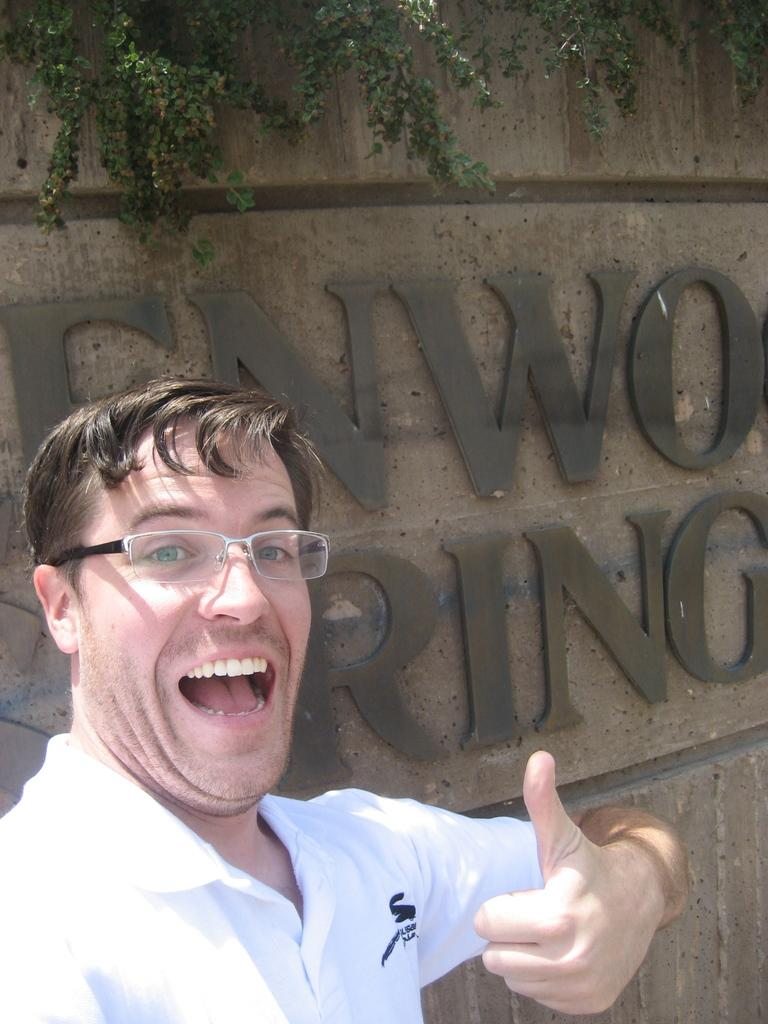Who is present in the image? There is a person in the image. What is the person doing in the image? The person is smiling. What can be seen on the wall behind the person? There is a wall with text on it behind the person. What type of natural element is visible at the top of the image? There are leaves of a tree visible at the top of the image. What verse is the person reciting in the image? There is no verse being recited in the image; the person is simply smiling. 